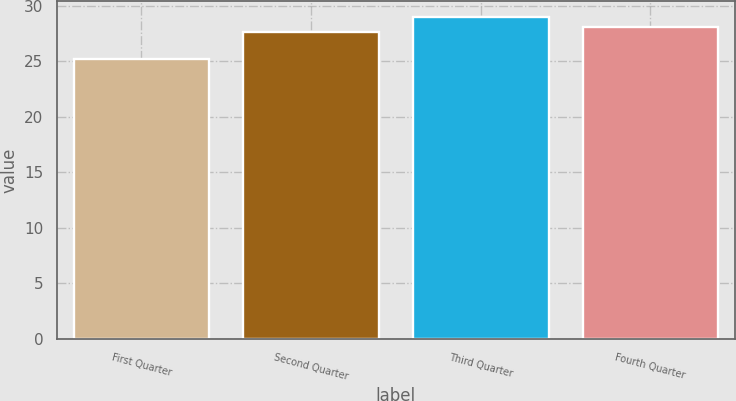Convert chart. <chart><loc_0><loc_0><loc_500><loc_500><bar_chart><fcel>First Quarter<fcel>Second Quarter<fcel>Third Quarter<fcel>Fourth Quarter<nl><fcel>25.15<fcel>27.65<fcel>28.97<fcel>28.03<nl></chart> 